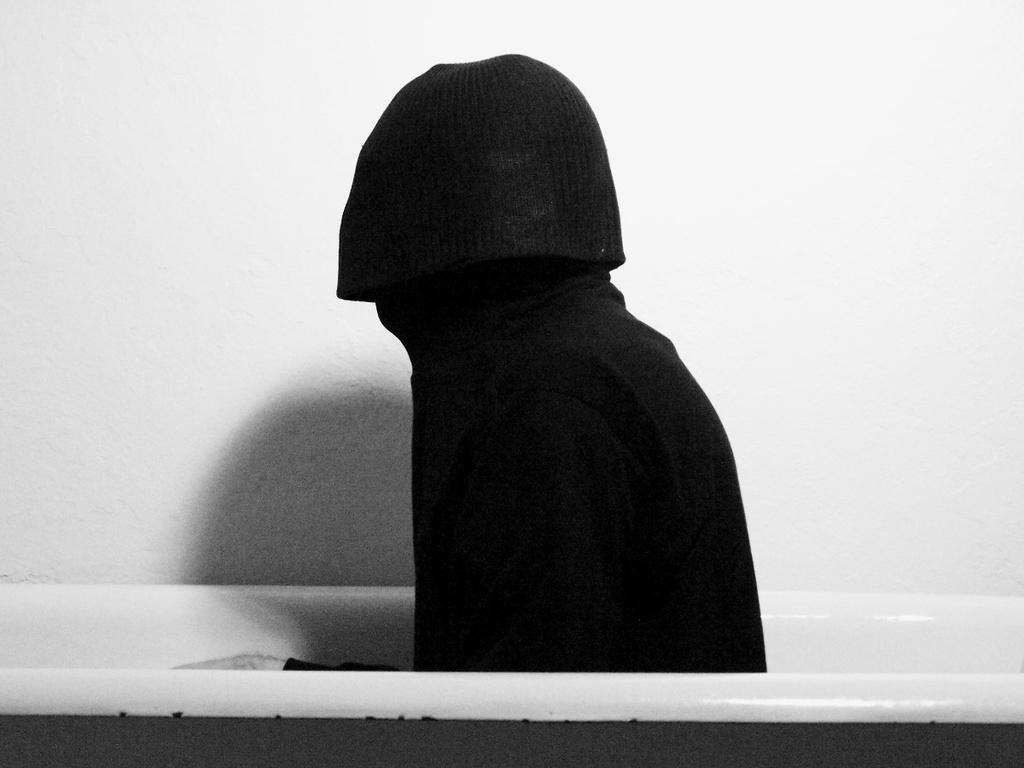What is the main object in the image? There is a bathtub in the image. Who or what is inside the bathtub? There is a person in the bathtub. What can be seen in the background of the image? There is a wall in the background of the image. How many desks are visible in the image? There are no desks present in the image; it features a bathtub with a person inside. What is the size of the rain in the image? There is no rain present in the image, so it is not possible to determine the size of any rain. 